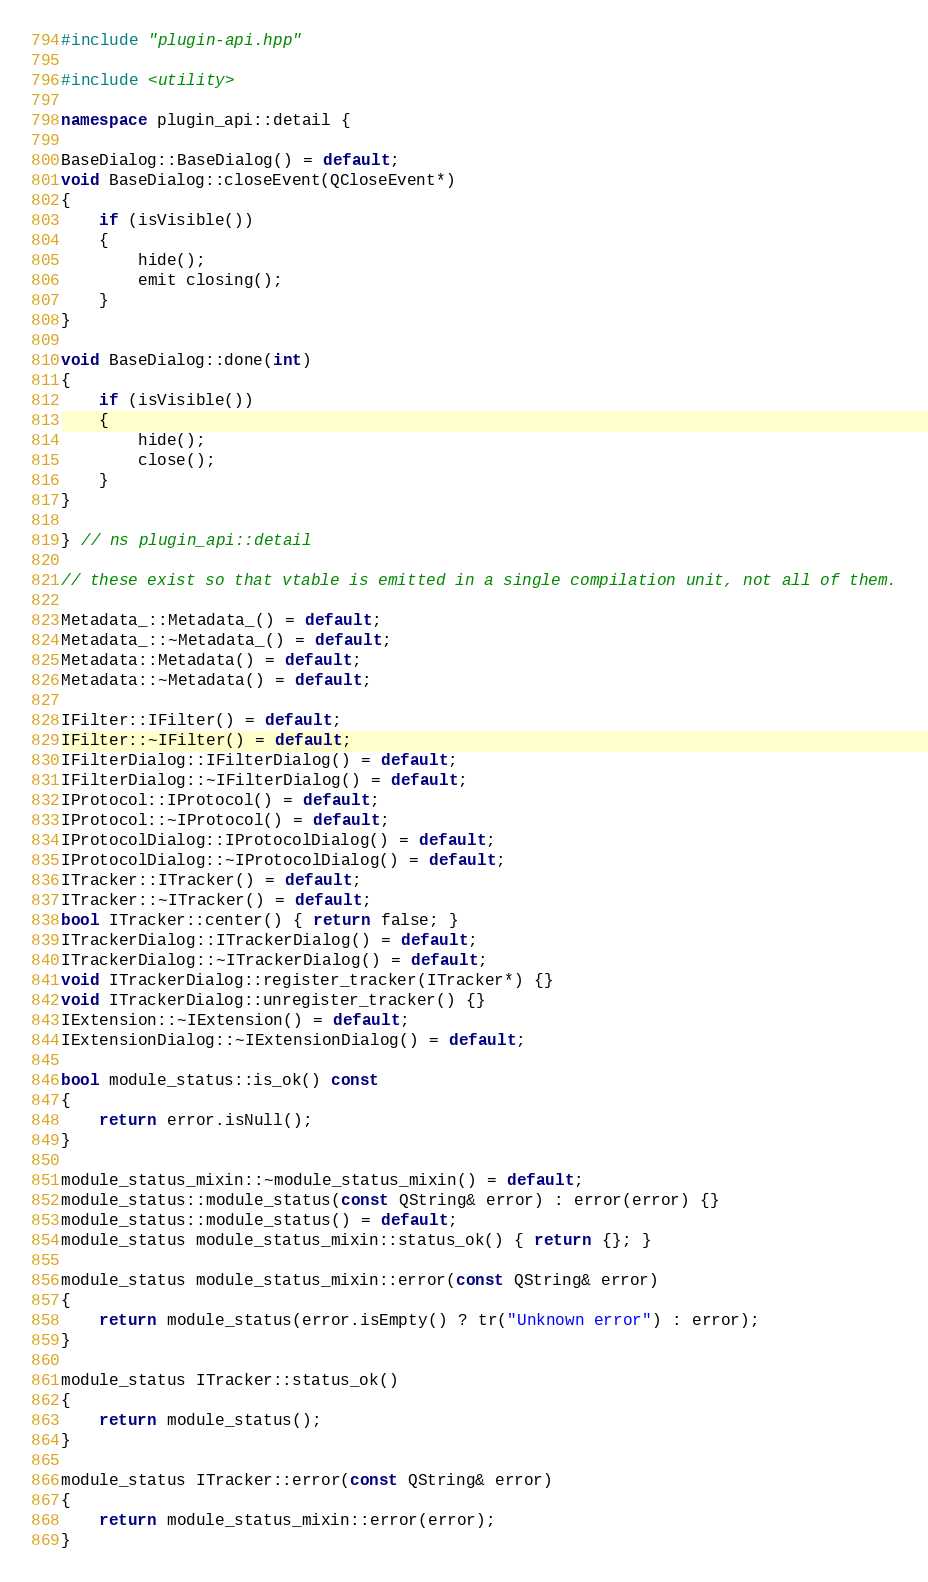Convert code to text. <code><loc_0><loc_0><loc_500><loc_500><_C++_>#include "plugin-api.hpp"

#include <utility>

namespace plugin_api::detail {

BaseDialog::BaseDialog() = default;
void BaseDialog::closeEvent(QCloseEvent*)
{
    if (isVisible())
    {
        hide();
        emit closing();
    }
}

void BaseDialog::done(int)
{
    if (isVisible())
    {
        hide();
        close();
    }
}

} // ns plugin_api::detail

// these exist so that vtable is emitted in a single compilation unit, not all of them.

Metadata_::Metadata_() = default;
Metadata_::~Metadata_() = default;
Metadata::Metadata() = default;
Metadata::~Metadata() = default;

IFilter::IFilter() = default;
IFilter::~IFilter() = default;
IFilterDialog::IFilterDialog() = default;
IFilterDialog::~IFilterDialog() = default;
IProtocol::IProtocol() = default;
IProtocol::~IProtocol() = default;
IProtocolDialog::IProtocolDialog() = default;
IProtocolDialog::~IProtocolDialog() = default;
ITracker::ITracker() = default;
ITracker::~ITracker() = default;
bool ITracker::center() { return false; }
ITrackerDialog::ITrackerDialog() = default;
ITrackerDialog::~ITrackerDialog() = default;
void ITrackerDialog::register_tracker(ITracker*) {}
void ITrackerDialog::unregister_tracker() {}
IExtension::~IExtension() = default;
IExtensionDialog::~IExtensionDialog() = default;

bool module_status::is_ok() const
{
    return error.isNull();
}

module_status_mixin::~module_status_mixin() = default;
module_status::module_status(const QString& error) : error(error) {}
module_status::module_status() = default;
module_status module_status_mixin::status_ok() { return {}; }

module_status module_status_mixin::error(const QString& error)
{
    return module_status(error.isEmpty() ? tr("Unknown error") : error);
}

module_status ITracker::status_ok()
{
    return module_status();
}

module_status ITracker::error(const QString& error)
{
    return module_status_mixin::error(error);
}
</code> 